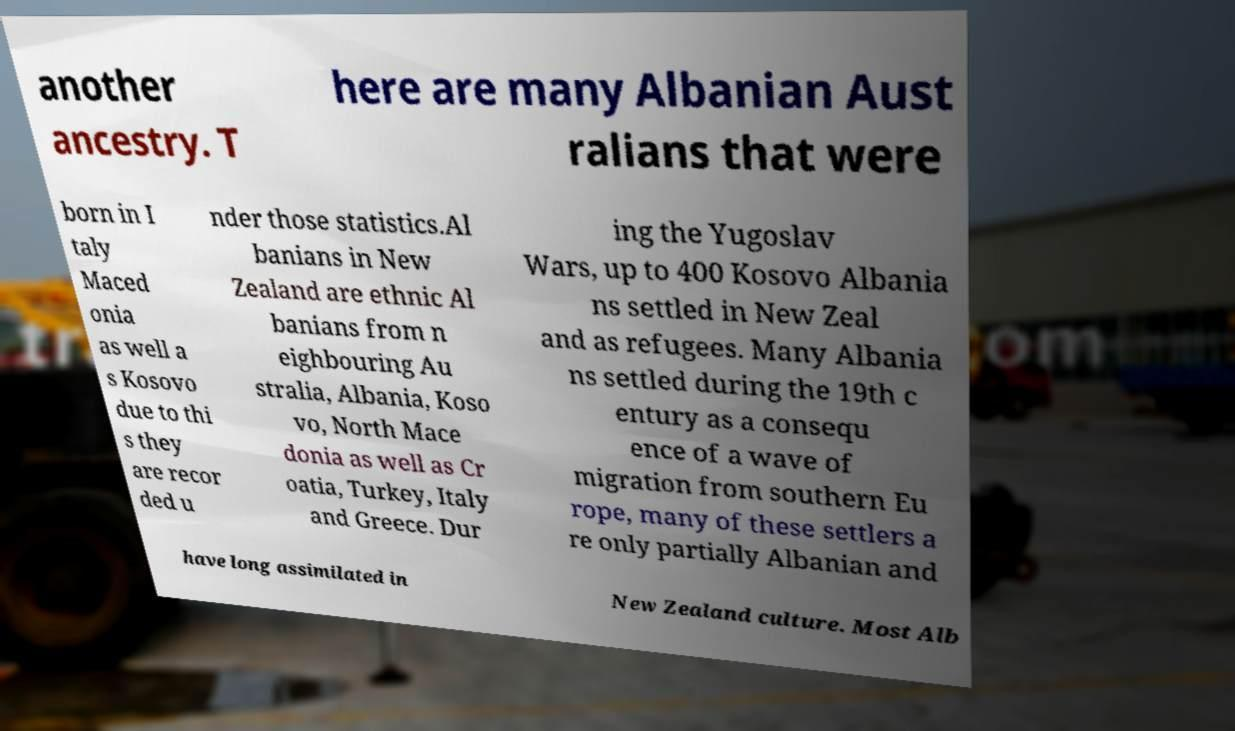Can you read and provide the text displayed in the image?This photo seems to have some interesting text. Can you extract and type it out for me? another ancestry. T here are many Albanian Aust ralians that were born in I taly Maced onia as well a s Kosovo due to thi s they are recor ded u nder those statistics.Al banians in New Zealand are ethnic Al banians from n eighbouring Au stralia, Albania, Koso vo, North Mace donia as well as Cr oatia, Turkey, Italy and Greece. Dur ing the Yugoslav Wars, up to 400 Kosovo Albania ns settled in New Zeal and as refugees. Many Albania ns settled during the 19th c entury as a consequ ence of a wave of migration from southern Eu rope, many of these settlers a re only partially Albanian and have long assimilated in New Zealand culture. Most Alb 